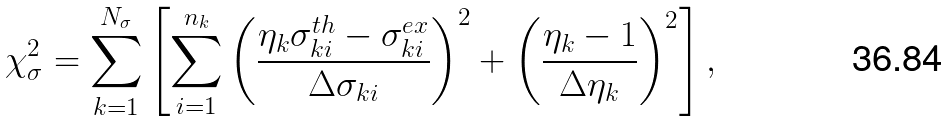Convert formula to latex. <formula><loc_0><loc_0><loc_500><loc_500>\chi ^ { 2 } _ { \sigma } = \sum _ { k = 1 } ^ { N _ { \sigma } } \left [ \sum _ { i = 1 } ^ { n _ { k } } \left ( \frac { \eta _ { k } \sigma ^ { t h } _ { k i } - \sigma ^ { e x } _ { k i } } { \Delta \sigma _ { k i } } \right ) ^ { 2 } + \left ( \frac { \eta _ { k } - 1 } { \Delta \eta _ { k } } \right ) ^ { 2 } \right ] ,</formula> 